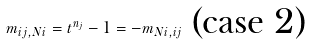<formula> <loc_0><loc_0><loc_500><loc_500>m _ { i j , N i } = t ^ { n _ { j } } - 1 = - m _ { N i , i j } \text { (case 2)}</formula> 